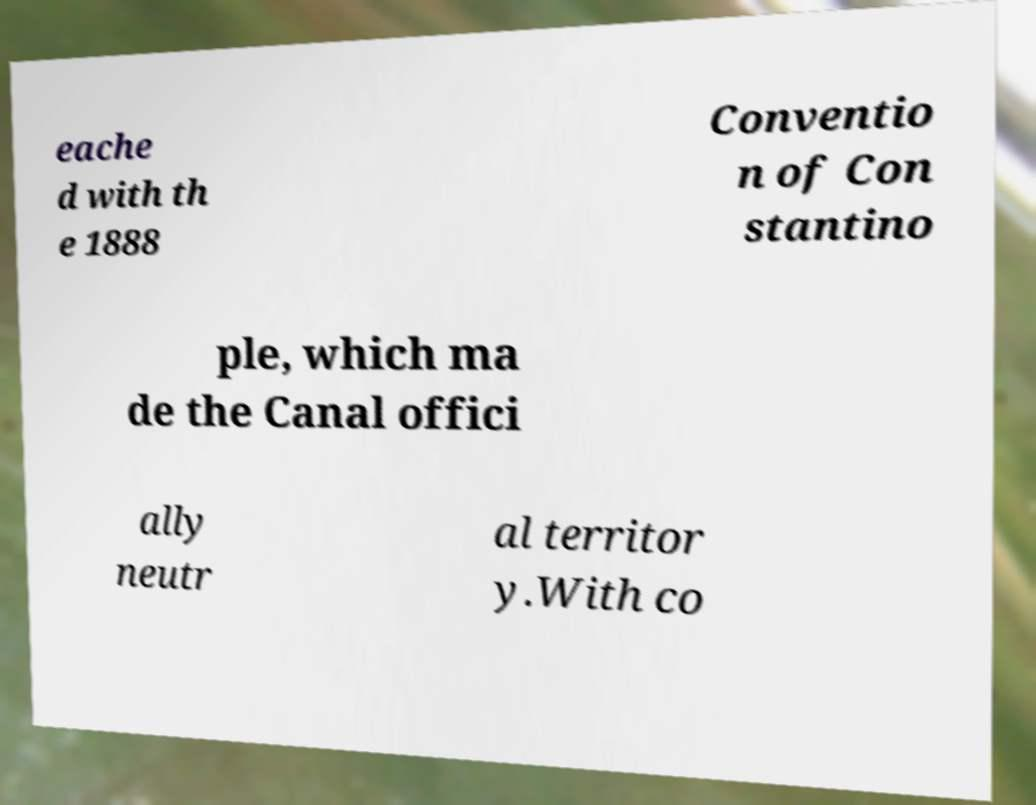Please read and relay the text visible in this image. What does it say? eache d with th e 1888 Conventio n of Con stantino ple, which ma de the Canal offici ally neutr al territor y.With co 